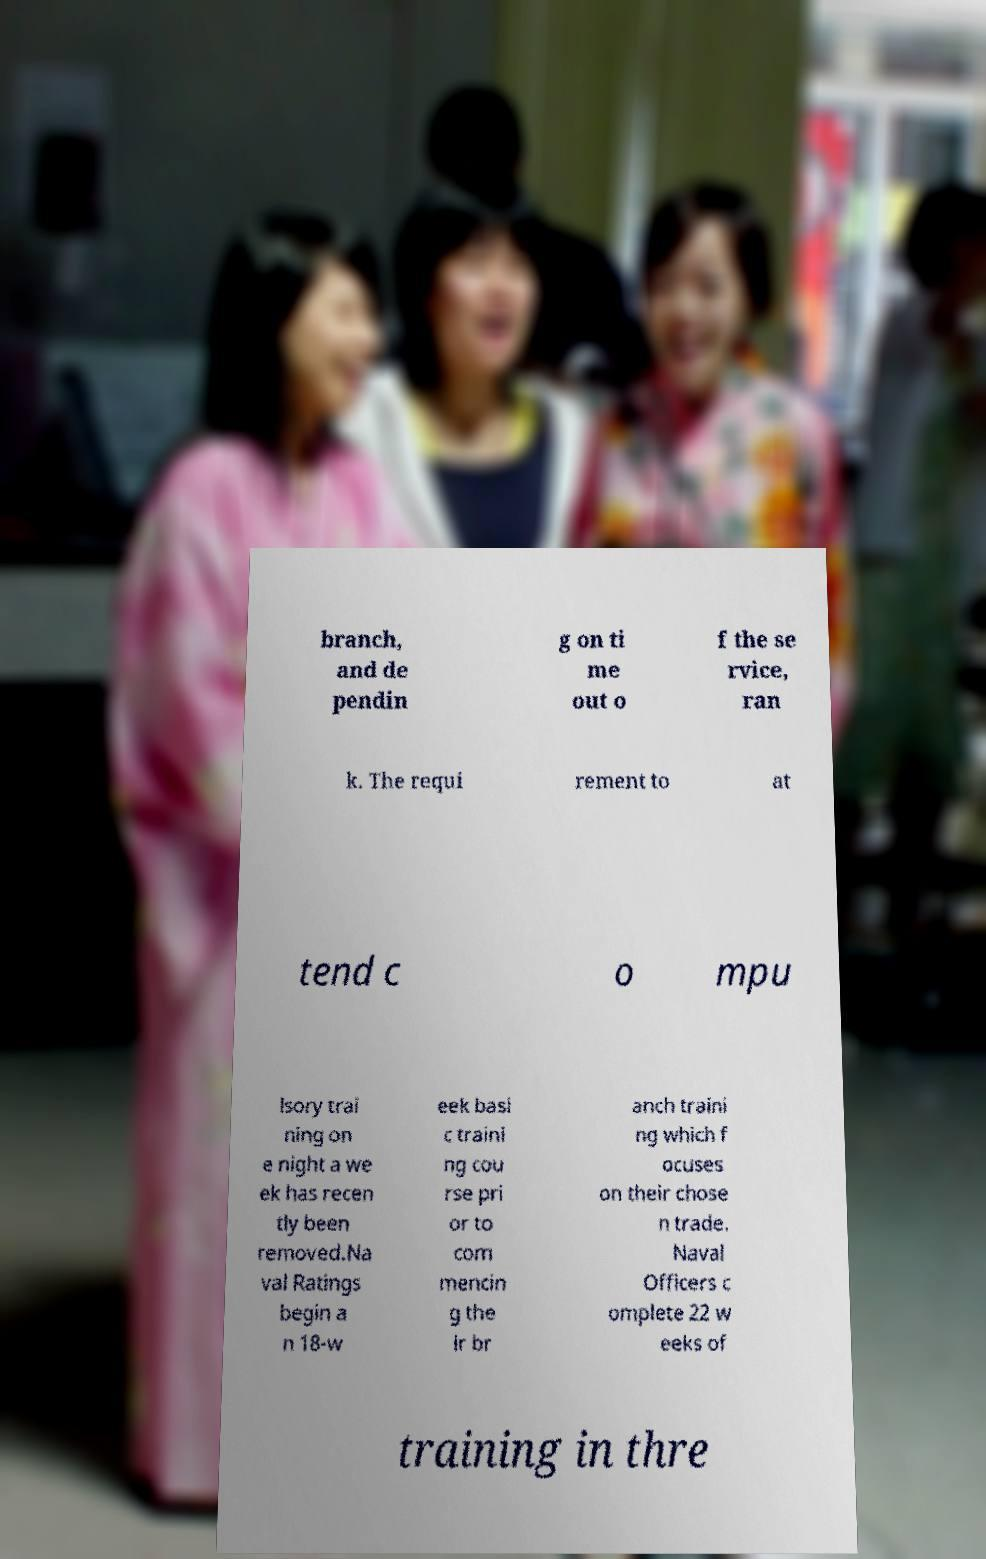Could you assist in decoding the text presented in this image and type it out clearly? branch, and de pendin g on ti me out o f the se rvice, ran k. The requi rement to at tend c o mpu lsory trai ning on e night a we ek has recen tly been removed.Na val Ratings begin a n 18-w eek basi c traini ng cou rse pri or to com mencin g the ir br anch traini ng which f ocuses on their chose n trade. Naval Officers c omplete 22 w eeks of training in thre 